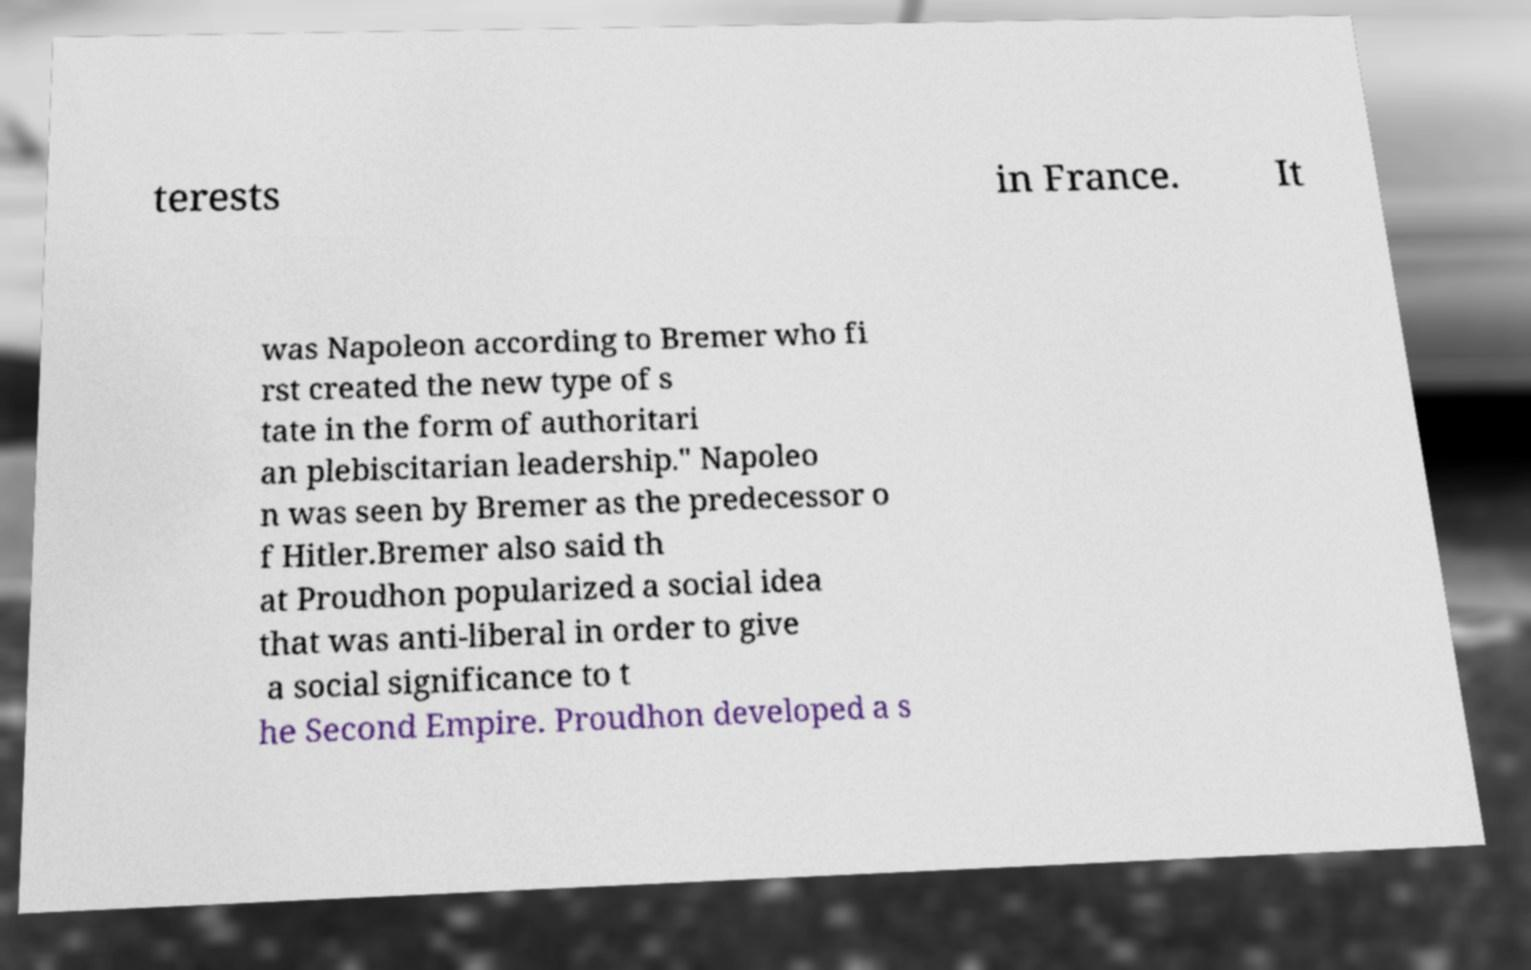I need the written content from this picture converted into text. Can you do that? terests in France. It was Napoleon according to Bremer who fi rst created the new type of s tate in the form of authoritari an plebiscitarian leadership." Napoleo n was seen by Bremer as the predecessor o f Hitler.Bremer also said th at Proudhon popularized a social idea that was anti-liberal in order to give a social significance to t he Second Empire. Proudhon developed a s 